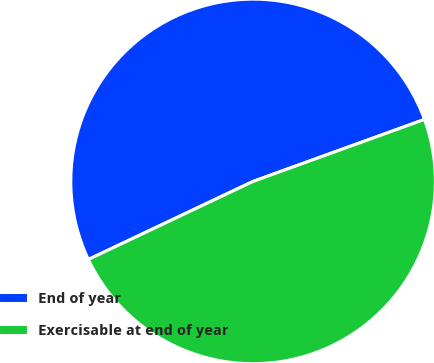Convert chart to OTSL. <chart><loc_0><loc_0><loc_500><loc_500><pie_chart><fcel>End of year<fcel>Exercisable at end of year<nl><fcel>51.52%<fcel>48.48%<nl></chart> 